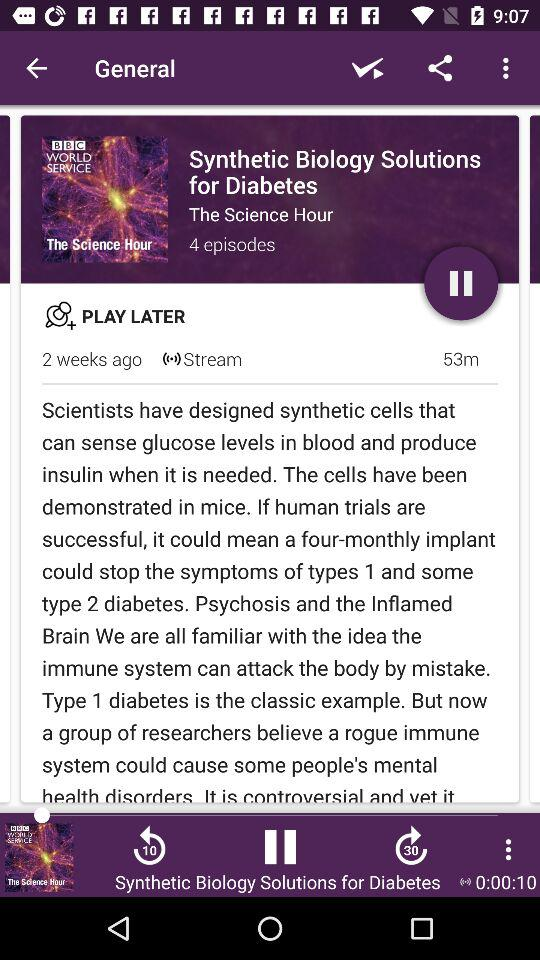When did it come? It came 2 weeks ago. 